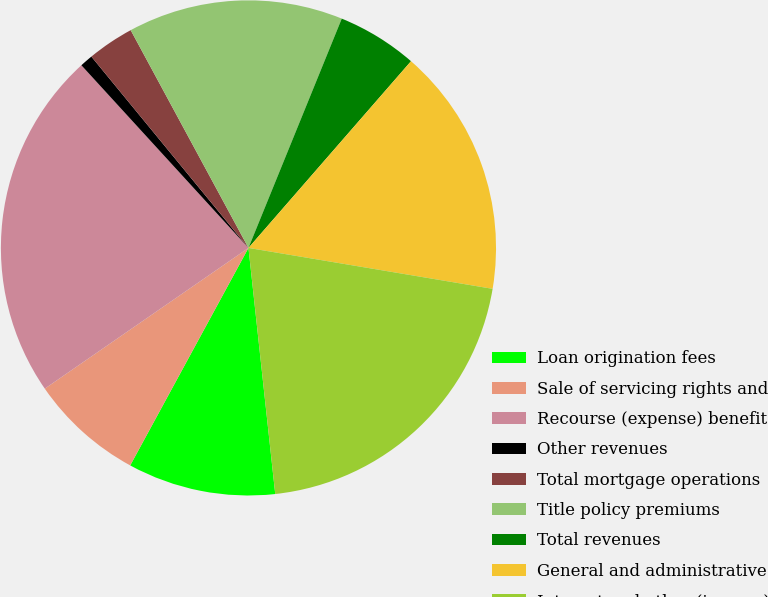<chart> <loc_0><loc_0><loc_500><loc_500><pie_chart><fcel>Loan origination fees<fcel>Sale of servicing rights and<fcel>Recourse (expense) benefit<fcel>Other revenues<fcel>Total mortgage operations<fcel>Title policy premiums<fcel>Total revenues<fcel>General and administrative<fcel>Interest and other (income)<nl><fcel>9.65%<fcel>7.45%<fcel>22.83%<fcel>0.85%<fcel>3.05%<fcel>14.04%<fcel>5.25%<fcel>16.24%<fcel>20.63%<nl></chart> 